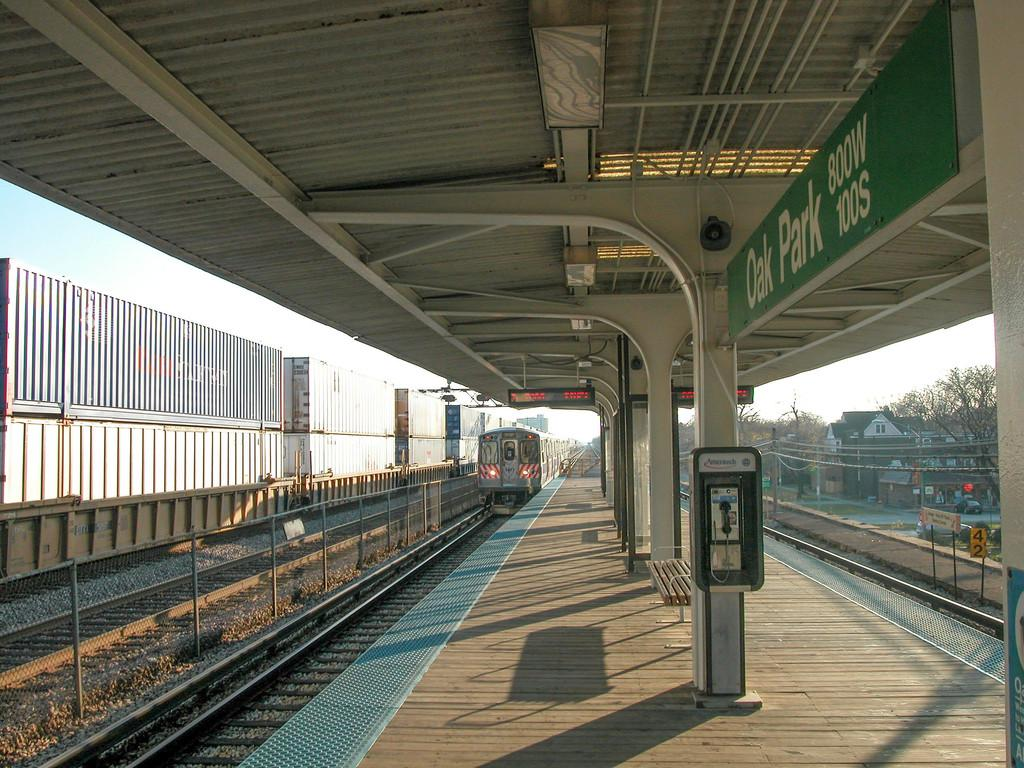What is the main subject of the image? The main subject of the image is a train. What is the train doing in the image? The train is moving in the image. What is located near the train in the image? There is a platform in the image. What type of structures can be seen in the image? There are buildings visible in the image. What type of vegetation can be seen in the image? There are trees in the image. What is the condition of the sky in the image? The sky is clear in the image. How many cats are sitting on the island in the image? There is no island or cats present in the image. What type of crib is visible in the image? There is no crib present in the image. 